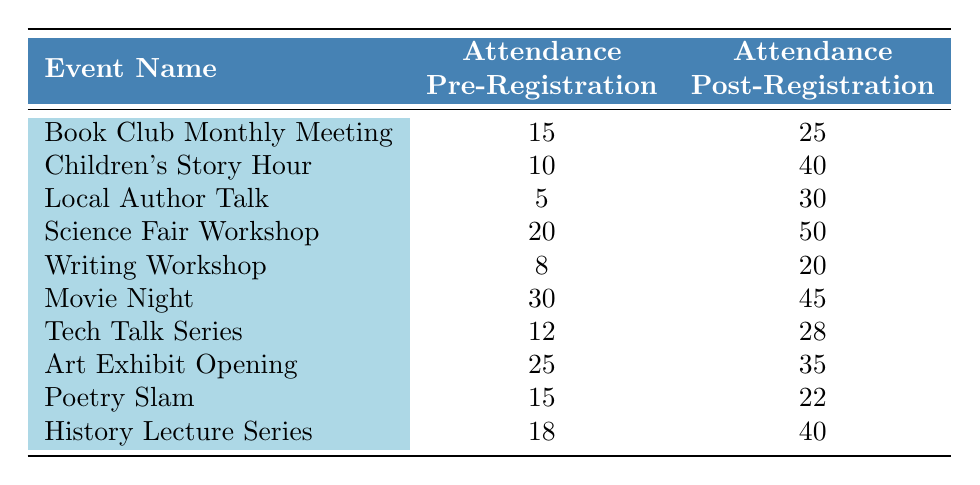What was the attendance for the "Local Author Talk" before online registration? The table indicates that the attendance before online registration for the "Local Author Talk" was 5.
Answer: 5 What is the increase in attendance for the "Science Fair Workshop" after introducing online registration? The attendance before registration was 20 and after registration was 50. The increase is calculated as 50 - 20 = 30.
Answer: 30 Did the "Writing Workshop" see an increase in attendance after online registration was introduced? The attendance before registration was 8, and after registration, it was 20. Since 20 is greater than 8, there was an increase in attendance.
Answer: Yes Which event had the highest attendance post-registration? Looking at the post-registration attendance figures, the "Science Fair Workshop" had the highest attendance at 50.
Answer: Science Fair Workshop What is the average attendance before registration across all events? To find the average, sum the pre-registration attendances (15 + 10 + 5 + 20 + 8 + 30 + 12 + 25 + 15 + 18 =  153) and divide by the number of events (10). The average is 153 / 10 = 15.3.
Answer: 15.3 Is it true that the "Children's Story Hour" had more than 30 attendees after registration? The attendance after registration for "Children's Story Hour" was 40, which is greater than 30. Therefore, the statement is true.
Answer: Yes What was the total attendance before registration for events that had less than 15 attendees? The events with attendance less than 15 pre-registration are "Local Author Talk" (5) and "Writing Workshop" (8). Summing these gives 5 + 8 = 13.
Answer: 13 How many events had an increase in attendance of 10 or more after registration? By examining the differences in attendance before and after registration, events with increases of 10 or more are: "Book Club Monthly Meeting" (10), "Children's Story Hour" (30), "Local Author Talk" (25), "Science Fair Workshop" (30), "Movie Night" (15), "Tech Talk Series" (16), "History Lecture Series" (22). Count of these events equals 7.
Answer: 7 Which event experienced the lowest attendance pre-registration? The "Local Author Talk" had the lowest pre-registration attendance at 5.
Answer: Local Author Talk 